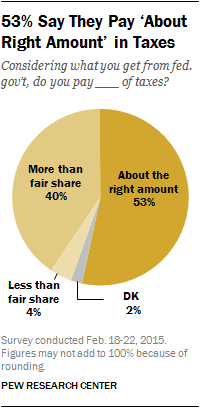Mention a couple of crucial points in this snapshot. The darkest orange color segment of the graph has a value of 53. The total added value of the smallest two segments is less than 'More than Fair Share'. 